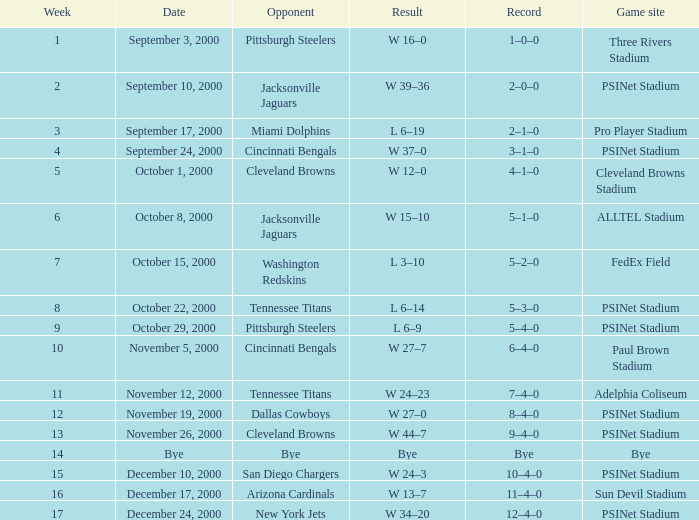What's the record after week 12 with a game site of bye? Bye. 